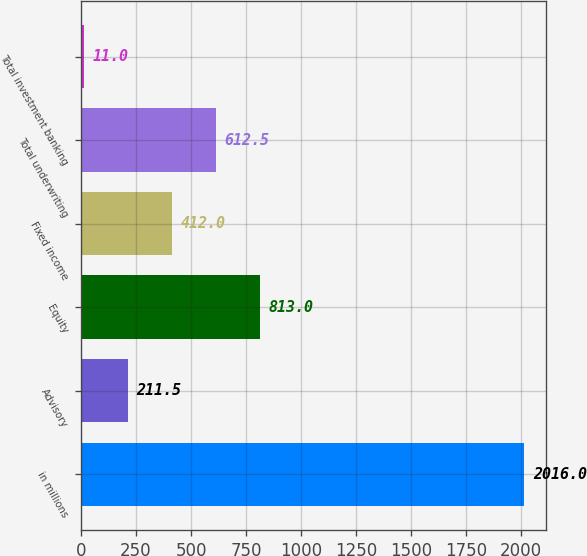<chart> <loc_0><loc_0><loc_500><loc_500><bar_chart><fcel>in millions<fcel>Advisory<fcel>Equity<fcel>Fixed income<fcel>Total underwriting<fcel>Total investment banking<nl><fcel>2016<fcel>211.5<fcel>813<fcel>412<fcel>612.5<fcel>11<nl></chart> 